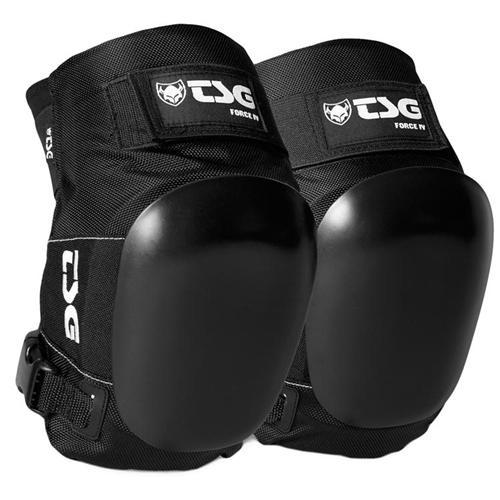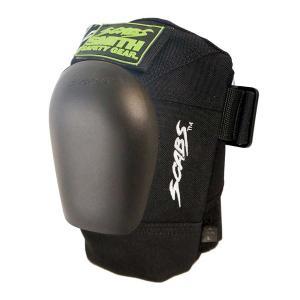The first image is the image on the left, the second image is the image on the right. For the images displayed, is the sentence "One image shows a pair of legs in shorts wearing a pair of black knee pads, and the other image features an unworn pair of black kneepads." factually correct? Answer yes or no. No. The first image is the image on the left, the second image is the image on the right. Given the left and right images, does the statement "The left and right image contains the same number of knee pads." hold true? Answer yes or no. No. 